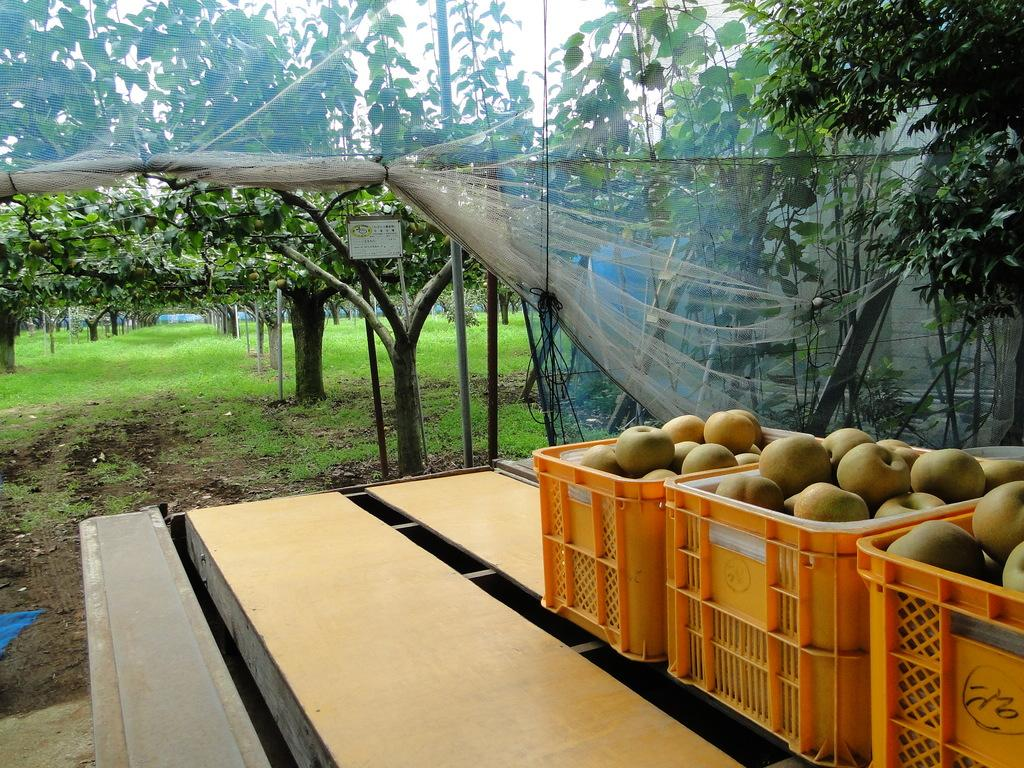What is the main object in the foreground of the image? There is a table in the image. What is placed on the table? There are baskets on the table, and they contain fruits. What can be seen in the background of the image? There are trees, grass, poles, a board, a net, and the sky visible in the background of the image. What type of education can be seen in the image? There is no reference to education in the image; it features a table with baskets of fruits and various background elements. What decision can be made based on the presence of a twig in the image? There is no twig present in the image, so no decision can be made based on its presence. 